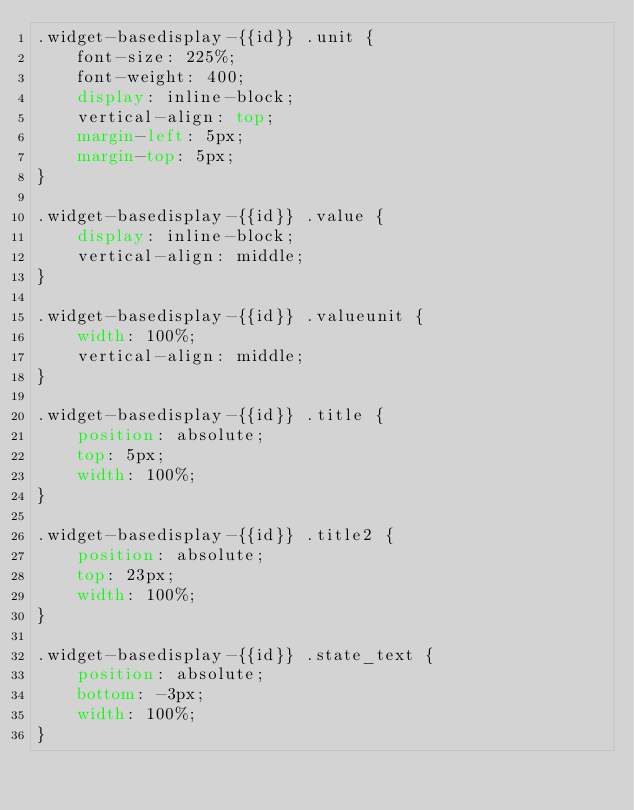Convert code to text. <code><loc_0><loc_0><loc_500><loc_500><_CSS_>.widget-basedisplay-{{id}} .unit {
	font-size: 225%;
	font-weight: 400;
	display: inline-block;
	vertical-align: top;
	margin-left: 5px;
	margin-top: 5px;
}

.widget-basedisplay-{{id}} .value {
	display: inline-block;
	vertical-align: middle;
}

.widget-basedisplay-{{id}} .valueunit {
	width: 100%;
	vertical-align: middle;
}

.widget-basedisplay-{{id}} .title {
	position: absolute;
	top: 5px;
	width: 100%;
}

.widget-basedisplay-{{id}} .title2 {
	position: absolute;
	top: 23px;
	width: 100%;
}

.widget-basedisplay-{{id}} .state_text {
	position: absolute;
	bottom: -3px;
	width: 100%;
}

</code> 